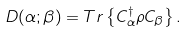Convert formula to latex. <formula><loc_0><loc_0><loc_500><loc_500>D ( \alpha ; \beta ) = T r \left \{ C _ { \alpha } ^ { \dag } \rho C _ { \beta } \right \} .</formula> 